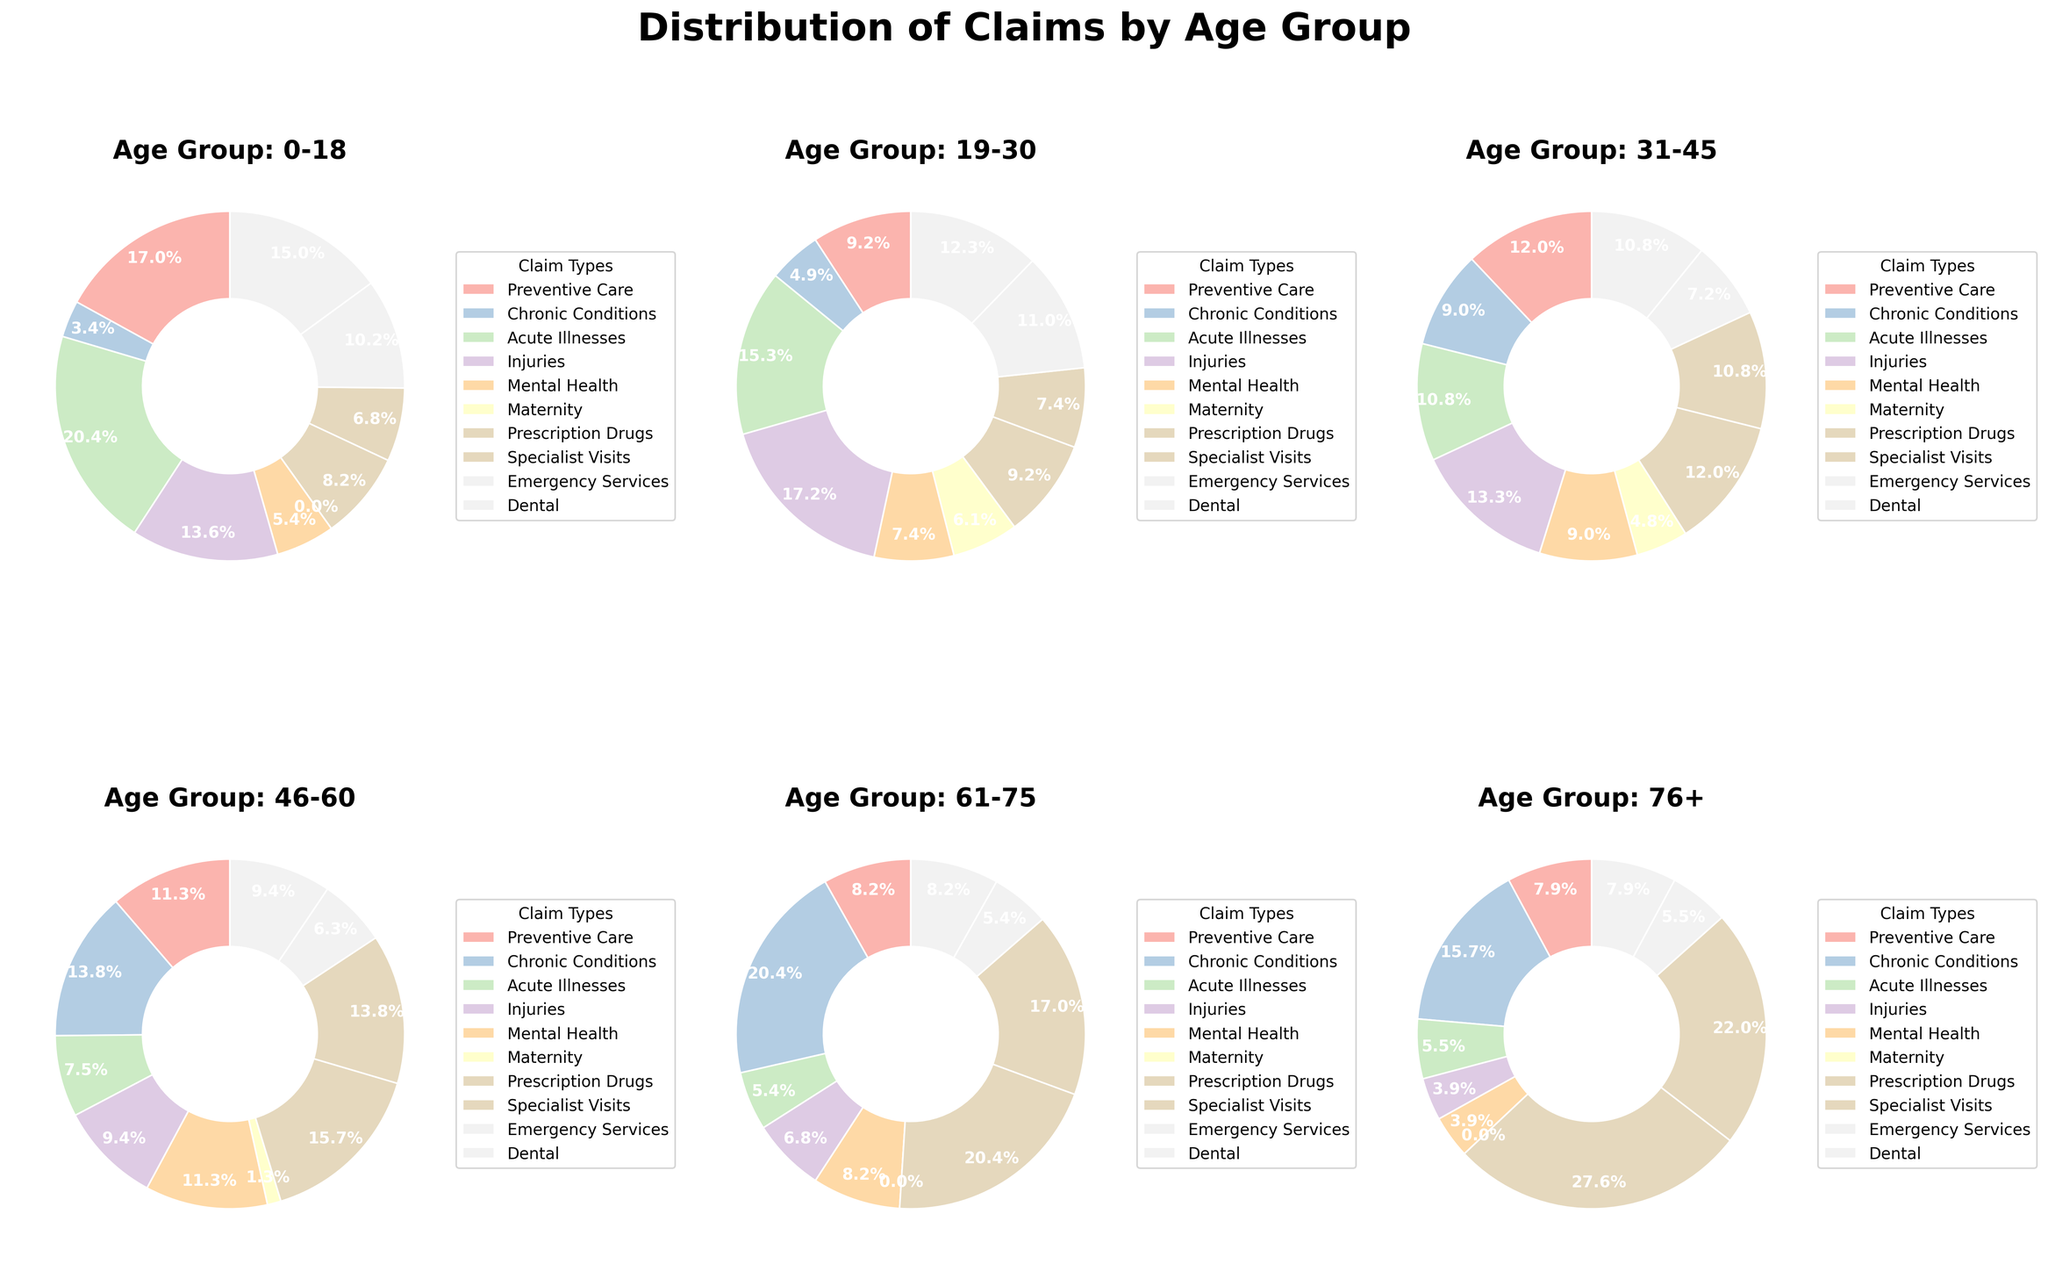Which age group has the highest percentage of claims for Preventive Care? Looking at the pie chart for Preventive Care, the 0-18 age group has the largest segment.
Answer: 0-18 Is the percentage of claims for Chronic Conditions higher in the 46-60 or the 76+ age group? The pie chart for Chronic Conditions shows that the 61-75 age group has a larger wedge compared to the 76+ age group.
Answer: 61-75 What is the total percentage of claims for Acute Illnesses in the age groups 19-30 and 31-45 combined? In the pie chart for Acute Illnesses, the 19-30 age group has 25% and the 31-45 age group has 18%. Combining these gives a total of 25% + 18% = 43%.
Answer: 43% Among the age groups, which one has the smallest percentage of claims for Injuries? In the pie chart for Injuries, the 76+ age group has the smallest segment.
Answer: 76+ Which age group has the same percentage of claims for Mental Health and Dental? In both the Mental Health and Dental pie charts, the 31-45 age group has the same percentage claims of 15%.
Answer: 31-45 How do the percentages of claims for Maternity differ between the 19-30 age group and the 31-45 age group? The pie chart for Maternity shows 19-30 with 10% and 31-45 with 8%. The difference is 10% - 8% = 2%.
Answer: 2% What is the average percentage of claims for Prescription Drugs across all age groups? The pie chart shows percentages of 12%, 15%, 20%, 25%, 30%, and 35% for Prescription Drugs. The average is (12 + 15 + 20 + 25 + 30 + 35) / 6 = 137 / 6 ≈ 22.83%.
Answer: 22.83% Do the age groups 46-60 and 61-75 have more claims for Specialist Visits or Emergency Services? Comparing the pie charts for Specialist Visits and Emergency Services, the combined percentages are 46-60 (22% + 10%) and 61-75 (25% + 8%). The sums are 32% for Specialist and 18% for Emergency Services.
Answer: Specialist Visits What is the percentage difference between claims for Preventive Care and Chronic Conditions in the 31-45 age group? In their respective pie charts, 31-45 age group has 20% for Preventive Care and 15% for Chronic Conditions. The difference is 20% - 15% = 5%.
Answer: 5% Which age group has the greatest disparity between claims for Preventive Care and Injuries? For the 0-18 age group, Preventive Care has 25% and Injuries have 20%. The disparity is 5%, the highest compared to other age groups.
Answer: 0-18 